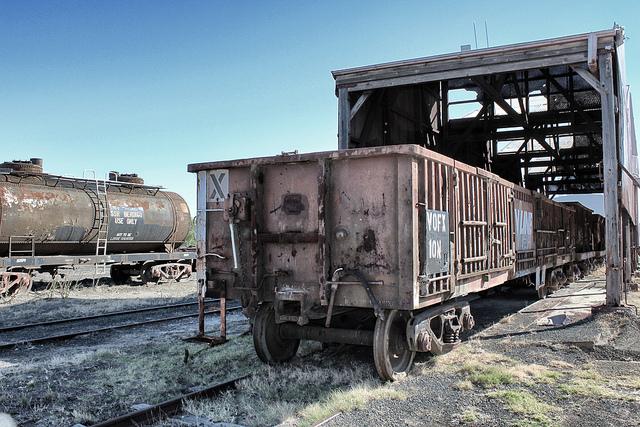What kind of fuel powers this locomotive?
Concise answer only. Coal. What letter is on the back?
Quick response, please. X. Is it raining?
Quick response, please. No. Is this equipment new?
Write a very short answer. No. 